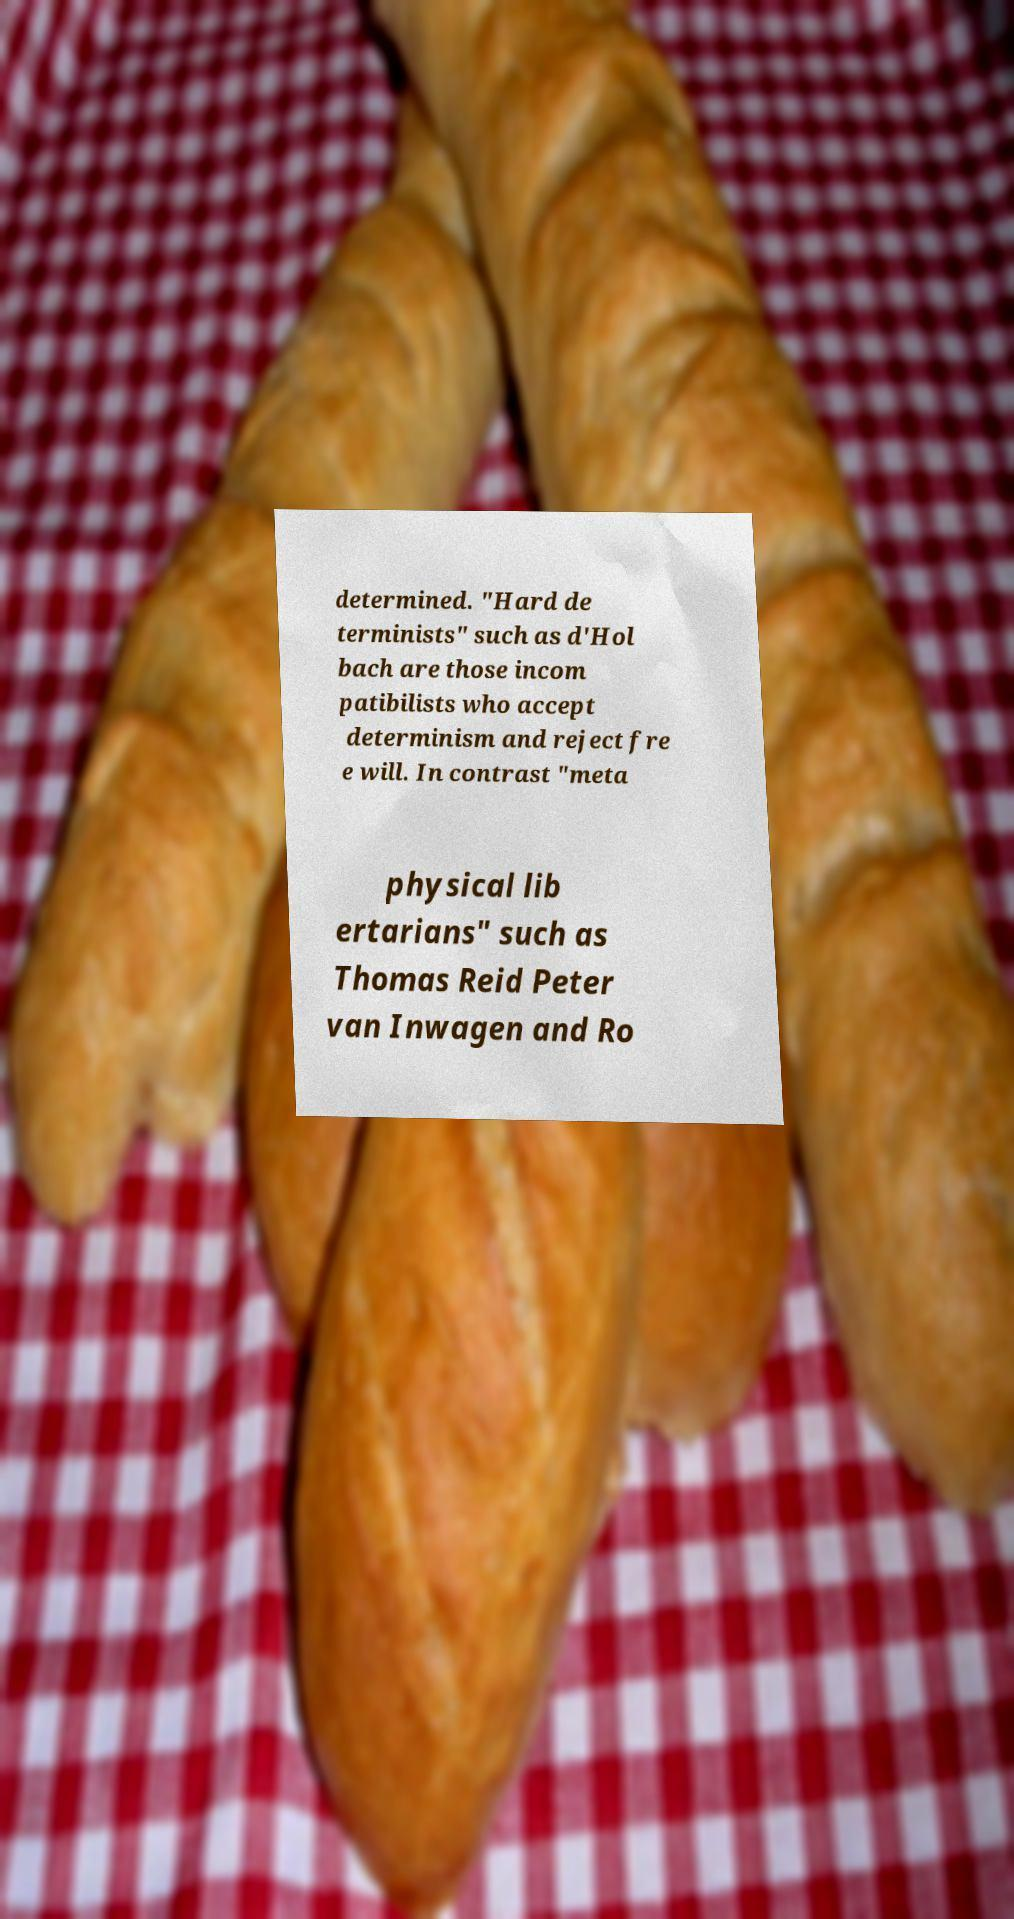Please read and relay the text visible in this image. What does it say? determined. "Hard de terminists" such as d'Hol bach are those incom patibilists who accept determinism and reject fre e will. In contrast "meta physical lib ertarians" such as Thomas Reid Peter van Inwagen and Ro 